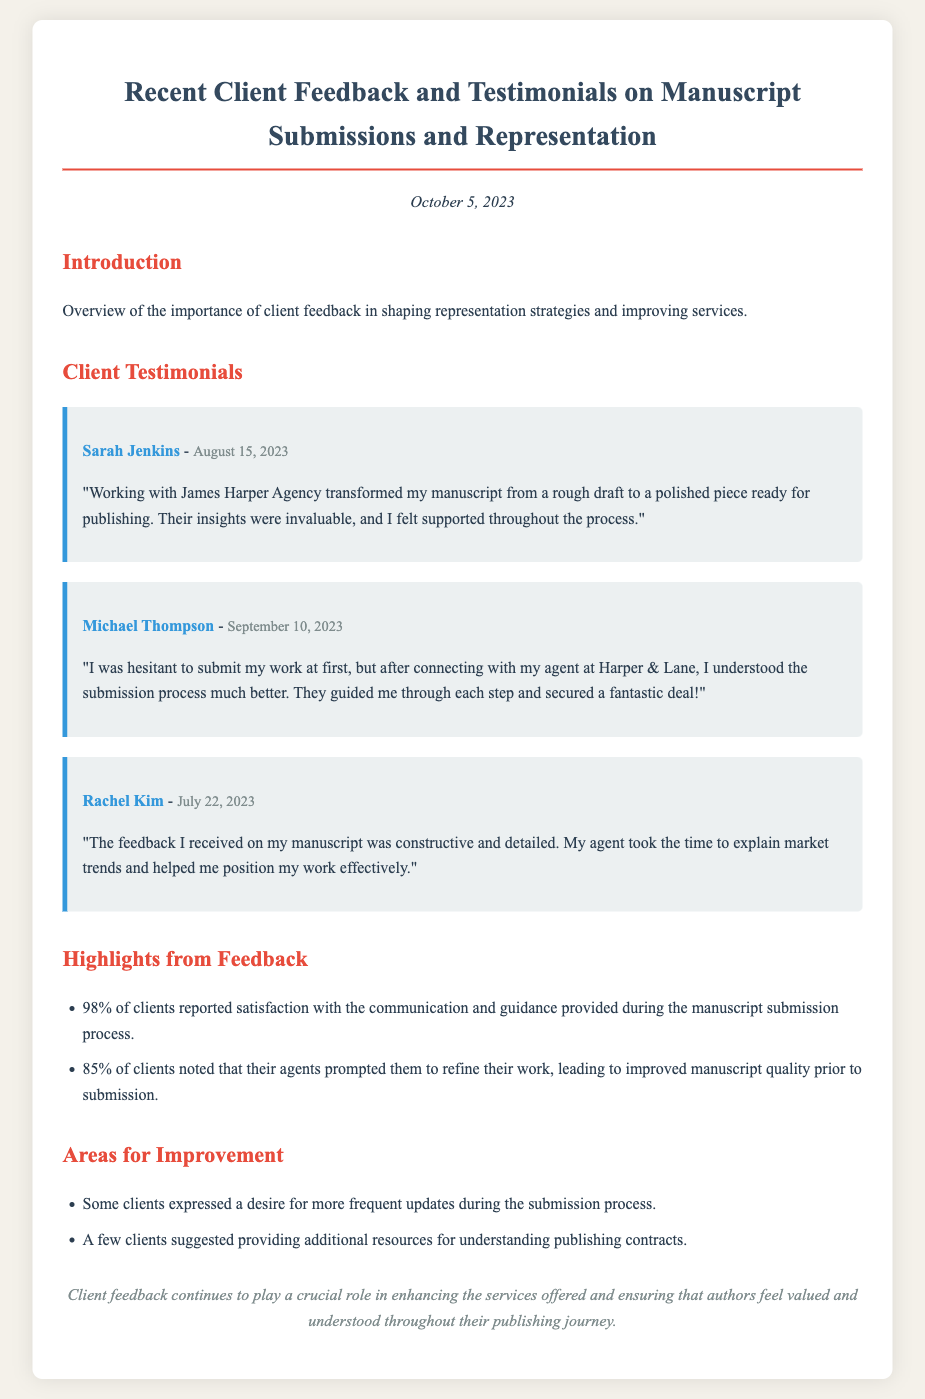What date is the document published? The document states that it was published on October 5, 2023.
Answer: October 5, 2023 Who provided feedback on August 15, 2023? The client feedback section includes testimonials with names and dates; Sarah Jenkins provided feedback on this date.
Answer: Sarah Jenkins What percentage of clients reported satisfaction with communication? The document mentions that 98% of clients reported satisfaction with communication and guidance.
Answer: 98% Which agency did Michael Thompson work with? Michael Thompson's testimonial indicates he worked with Harper & Lane.
Answer: Harper & Lane What does the feedback suggest regarding the submission process? Clients' feedback indicates they expressed a desire for more frequent updates during the submission process.
Answer: More frequent updates How many clients noted improvements in manuscript quality? The document states that 85% of clients noted that their agents prompted them to refine their work.
Answer: 85% What was the overall sentiment expressed in the conclusion? The conclusion reflects that client feedback is crucial for enhancing services and ensuring authors feel valued.
Answer: Crucial for enhancing services 